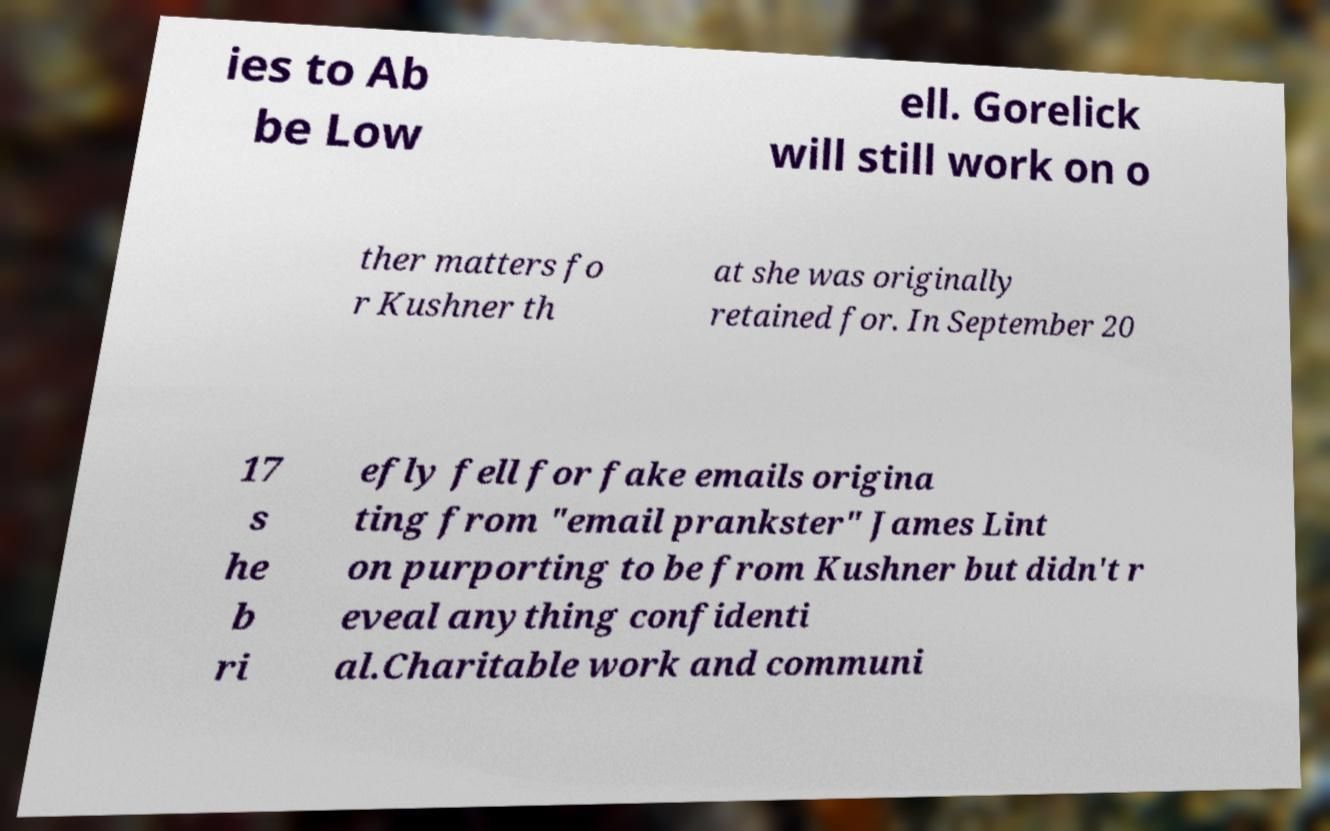What messages or text are displayed in this image? I need them in a readable, typed format. ies to Ab be Low ell. Gorelick will still work on o ther matters fo r Kushner th at she was originally retained for. In September 20 17 s he b ri efly fell for fake emails origina ting from "email prankster" James Lint on purporting to be from Kushner but didn't r eveal anything confidenti al.Charitable work and communi 